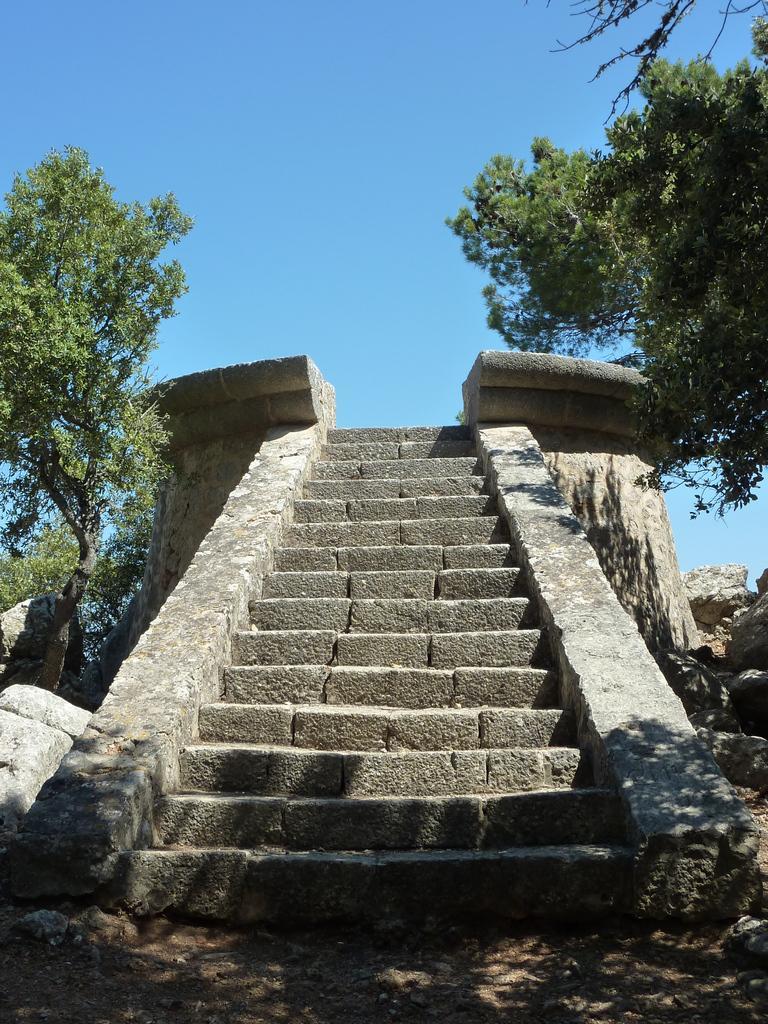How would you summarize this image in a sentence or two? In this image we can see the stairs. And we can see the trees. And we can see the sky. And we can see the rocks. 